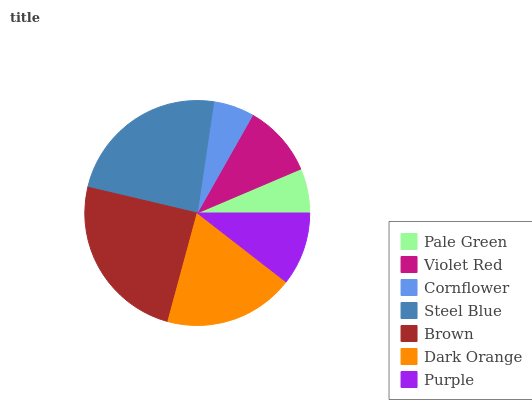Is Cornflower the minimum?
Answer yes or no. Yes. Is Brown the maximum?
Answer yes or no. Yes. Is Violet Red the minimum?
Answer yes or no. No. Is Violet Red the maximum?
Answer yes or no. No. Is Violet Red greater than Pale Green?
Answer yes or no. Yes. Is Pale Green less than Violet Red?
Answer yes or no. Yes. Is Pale Green greater than Violet Red?
Answer yes or no. No. Is Violet Red less than Pale Green?
Answer yes or no. No. Is Purple the high median?
Answer yes or no. Yes. Is Purple the low median?
Answer yes or no. Yes. Is Violet Red the high median?
Answer yes or no. No. Is Brown the low median?
Answer yes or no. No. 